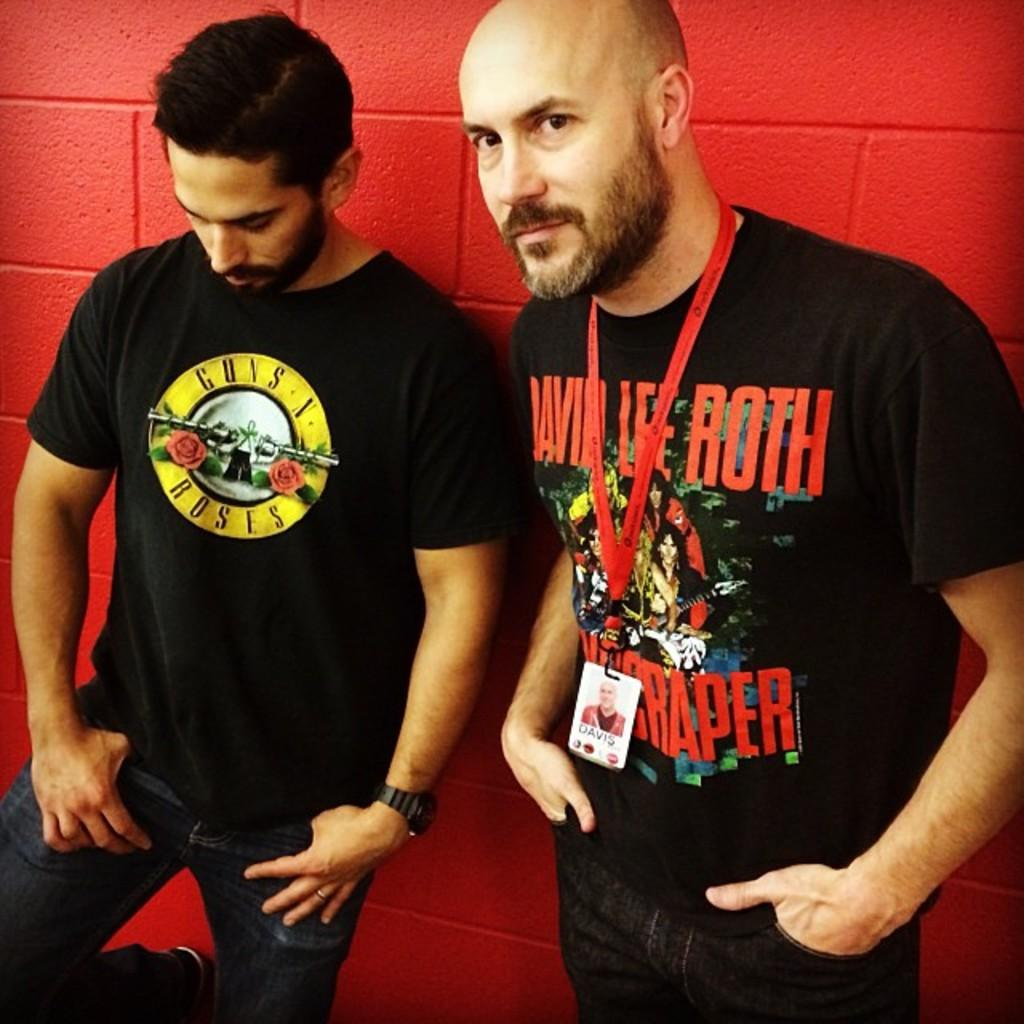<image>
Share a concise interpretation of the image provided. guns and roses is the shirt someone is wearing 